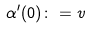Convert formula to latex. <formula><loc_0><loc_0><loc_500><loc_500>\alpha ^ { \prime } ( 0 ) \colon = v</formula> 